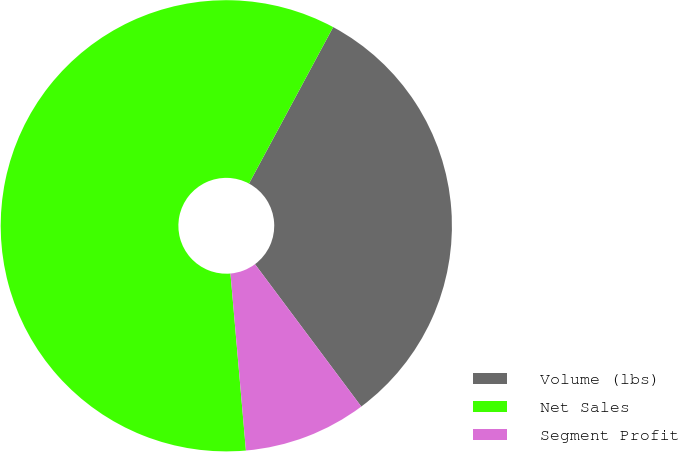Convert chart. <chart><loc_0><loc_0><loc_500><loc_500><pie_chart><fcel>Volume (lbs)<fcel>Net Sales<fcel>Segment Profit<nl><fcel>31.94%<fcel>59.24%<fcel>8.82%<nl></chart> 